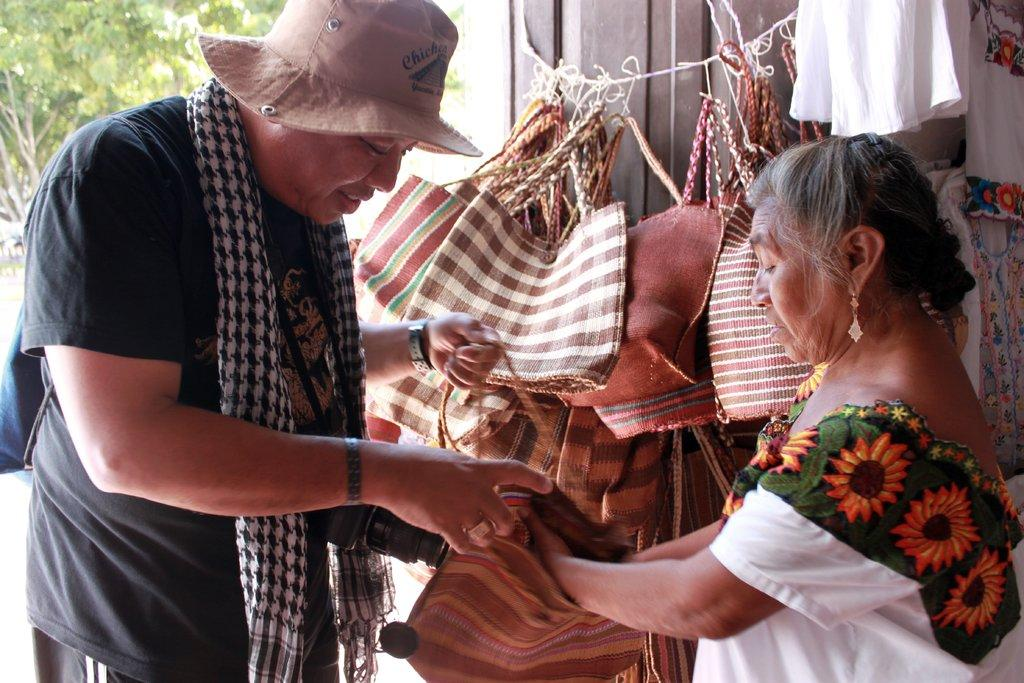How many people are present in the image? There are two people in the image. What are the people holding in their hands? The people are holding bags in their hands. Can you describe the background of the image? There are bags and trees visible in the background of the image. What type of body is visible in the image? There is no body present in the image; it features two people holding bags. 